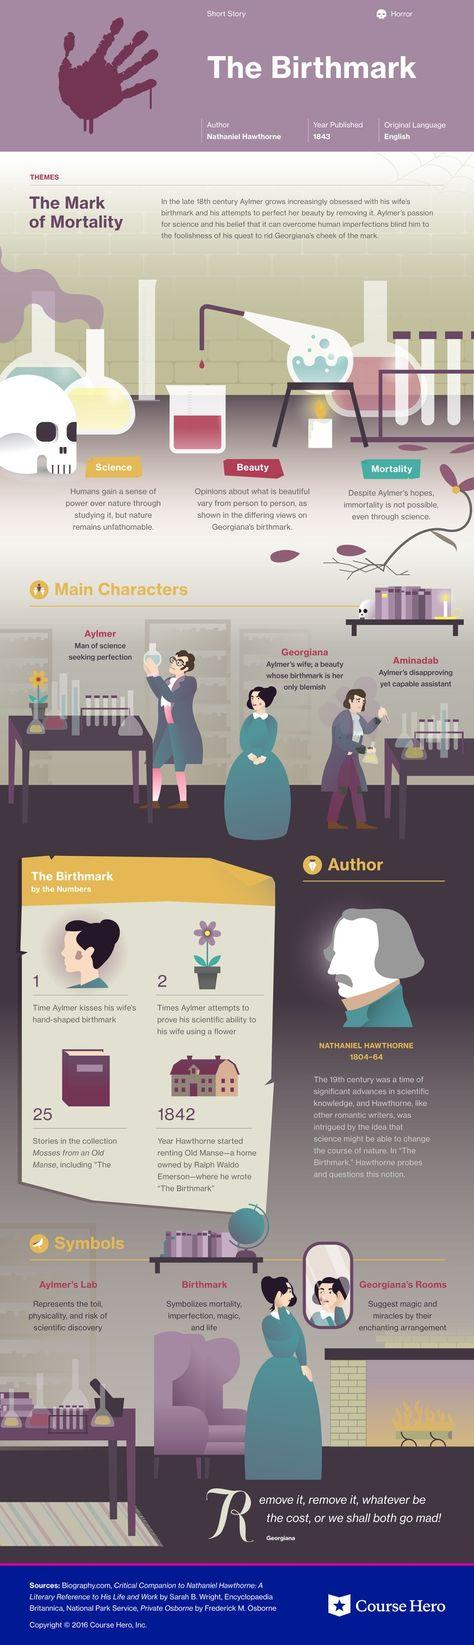Point out several critical features in this image. Aylmer is the main protagonist of this fiction. Nathaniel Hawthorne's book "The Mark of Mortality" explores the topics of science, beauty, and mortality. 